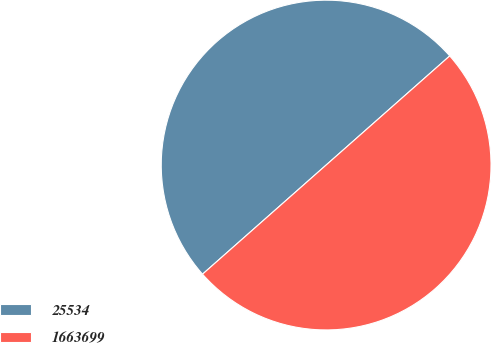Convert chart to OTSL. <chart><loc_0><loc_0><loc_500><loc_500><pie_chart><fcel>25534<fcel>1663699<nl><fcel>50.0%<fcel>50.0%<nl></chart> 